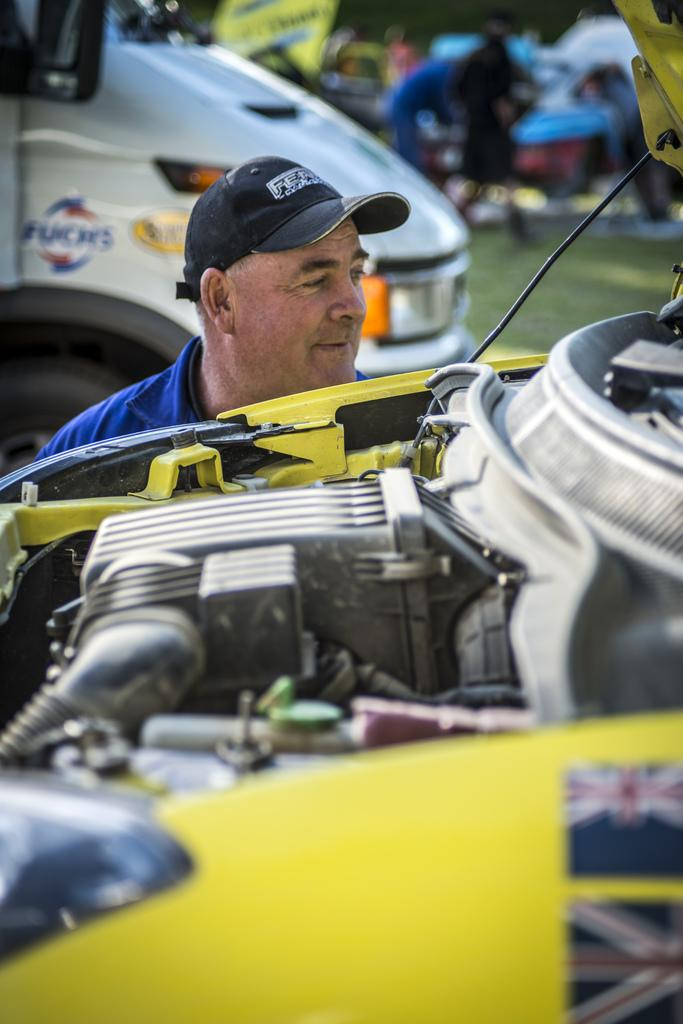What is the man doing in the image? The man is beside the engine of a car. What can be seen behind the man? There is a car on the backside. What is the location of the objects mentioned in the image? The objects are on a grass field. What type of cough is the man experiencing while working on the car? There is no indication in the image that the man is experiencing a cough, so it cannot be determined from the picture. 